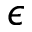<formula> <loc_0><loc_0><loc_500><loc_500>\epsilon</formula> 